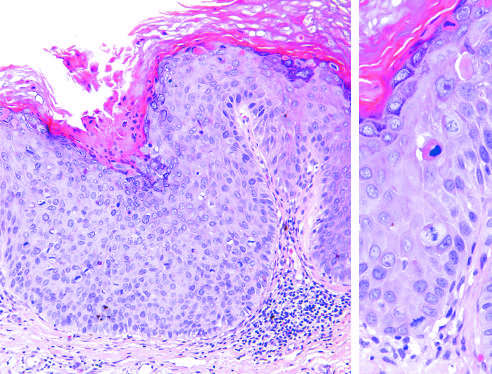what does the epithelium above the intact basement membrane show?
Answer the question using a single word or phrase. Delayed maturation and disorganization 